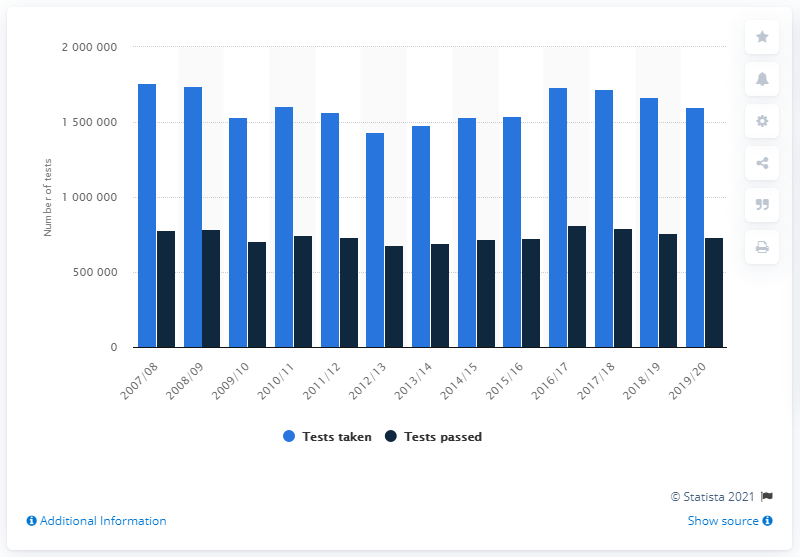Point out several critical features in this image. In the UK during the 2019/2020 fiscal year, a total of 159,956 practical driving tests were conducted. In the year 2019/20, a total of 159,956 practical driving tests were successfully completed in the UK. 